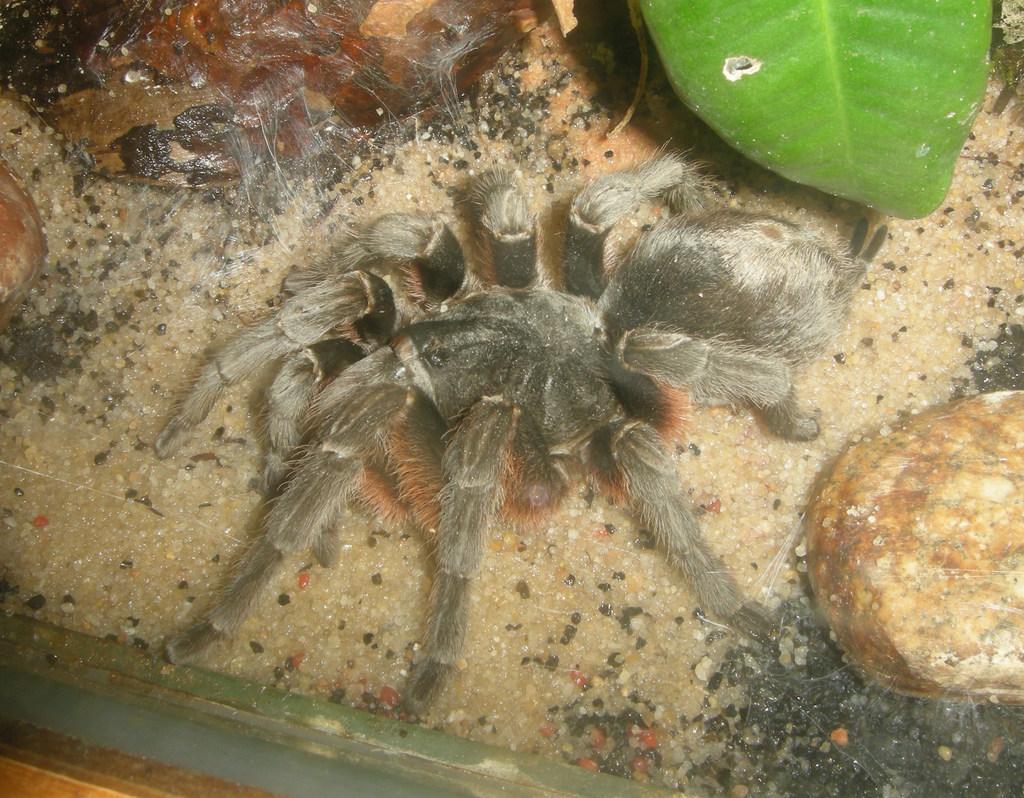Describe this image in one or two sentences. In this image I can see the spider which is in black and ash color. To the side of the spider there is a rock and green color leaf. I can also see few other objects to the side. 